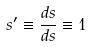<formula> <loc_0><loc_0><loc_500><loc_500>s ^ { \prime } \equiv \frac { d s } { d s } \equiv 1</formula> 